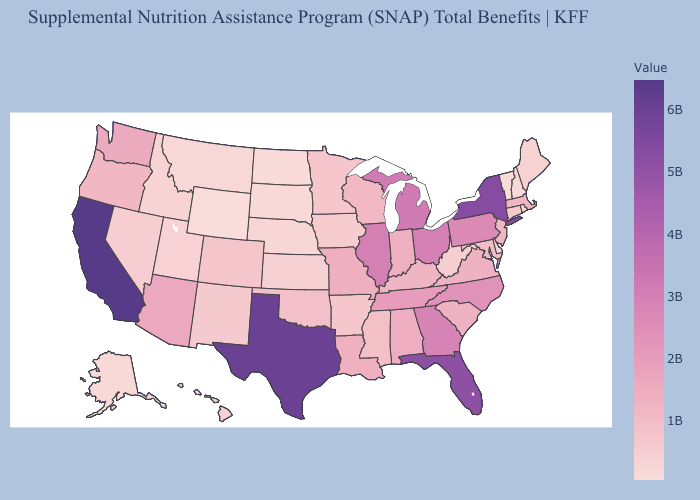Among the states that border Wyoming , which have the highest value?
Keep it brief. Colorado. Among the states that border Rhode Island , which have the lowest value?
Quick response, please. Connecticut. Does Washington have the lowest value in the USA?
Write a very short answer. No. Among the states that border Washington , which have the lowest value?
Answer briefly. Idaho. Does Washington have a higher value than California?
Write a very short answer. No. Among the states that border South Carolina , does Georgia have the lowest value?
Answer briefly. No. 